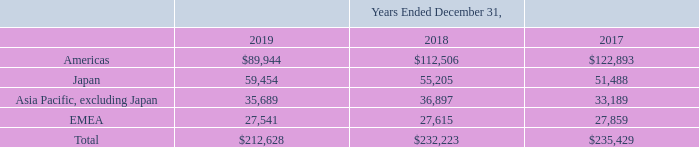12. Geographic Information
The following table depicts the disaggregation of revenue by geographic region based on the ship to location of our customers and is consistent with how we evaluate our financial performance (in thousands)
What data is shown in the table? Disaggregation of revenue by geographic region. What is the units for the data shown in the table? In thousands. What is the total revenue earned by the company in 2019? $212,628. What is the total revenue earned by the company between 2017 to 2019?
Answer scale should be: thousand. $212,628 + $232,223 + $235,429 
Answer: 680280. What is the total revenue earned in EMEA between 2017 to 2019?
Answer scale should be: thousand. 27,541 + 27,615 + 27,859
Answer: 83015. What is the change in total revenue between 2018 to 2019?
Answer scale should be: percent. ($212,628 - $232,223)/$232,223 
Answer: -8.44. 